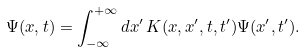<formula> <loc_0><loc_0><loc_500><loc_500>\Psi ( x , t ) = \int ^ { + \infty } _ { - \infty } d x ^ { \prime } \, K ( x , x ^ { \prime } , t , t ^ { \prime } ) \Psi ( x ^ { \prime } , t ^ { \prime } ) .</formula> 